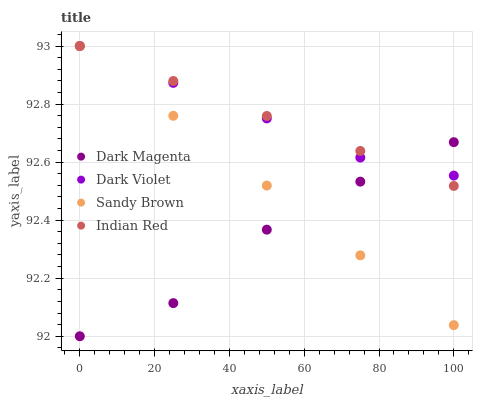Does Dark Magenta have the minimum area under the curve?
Answer yes or no. Yes. Does Indian Red have the maximum area under the curve?
Answer yes or no. Yes. Does Sandy Brown have the minimum area under the curve?
Answer yes or no. No. Does Sandy Brown have the maximum area under the curve?
Answer yes or no. No. Is Sandy Brown the smoothest?
Answer yes or no. Yes. Is Dark Magenta the roughest?
Answer yes or no. Yes. Is Dark Magenta the smoothest?
Answer yes or no. No. Is Sandy Brown the roughest?
Answer yes or no. No. Does Dark Magenta have the lowest value?
Answer yes or no. Yes. Does Sandy Brown have the lowest value?
Answer yes or no. No. Does Dark Violet have the highest value?
Answer yes or no. Yes. Does Dark Magenta have the highest value?
Answer yes or no. No. Does Indian Red intersect Dark Magenta?
Answer yes or no. Yes. Is Indian Red less than Dark Magenta?
Answer yes or no. No. Is Indian Red greater than Dark Magenta?
Answer yes or no. No. 